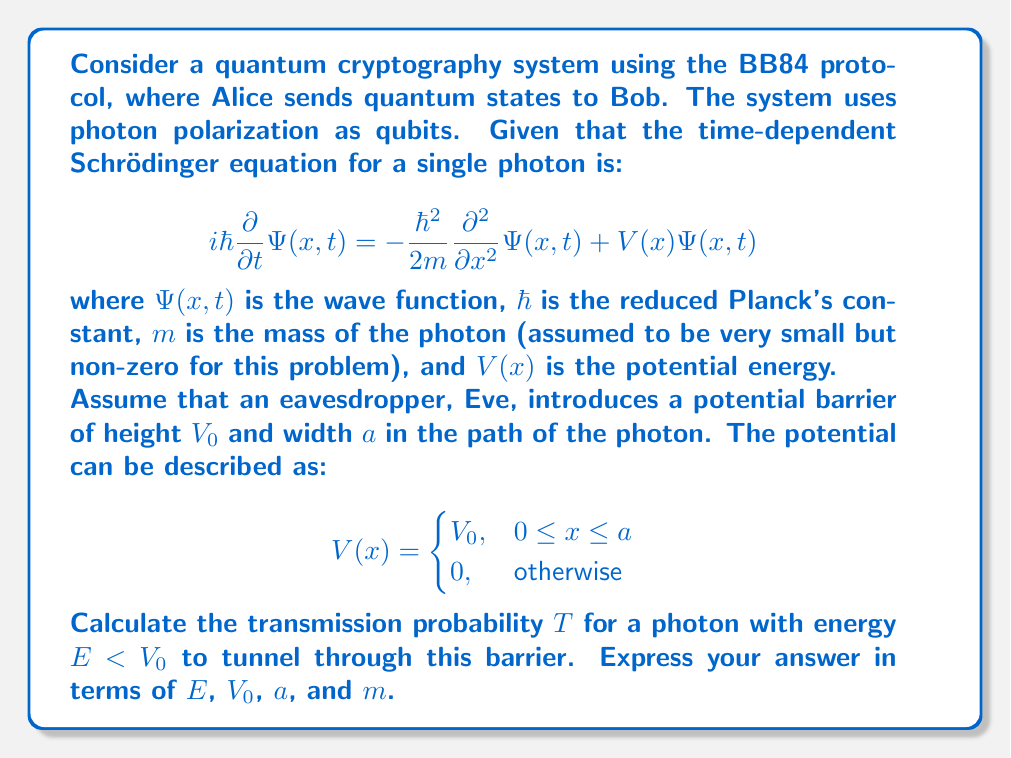What is the answer to this math problem? To solve this problem, we need to follow these steps:

1) First, we recognize that this is a quantum tunneling problem through a rectangular potential barrier.

2) For a time-independent solution, we can separate the wave function into spatial and temporal parts:
   
   $\Psi(x,t) = \psi(x)e^{-iEt/\hbar}$

3) This leads to the time-independent Schrödinger equation:

   $$-\frac{\hbar^2}{2m} \frac{d^2\psi}{dx^2} + V(x)\psi = E\psi$$

4) We need to solve this equation in three regions:
   I: $x < 0$ (before the barrier)
   II: $0 \leq x \leq a$ (inside the barrier)
   III: $x > a$ (after the barrier)

5) The general solutions in each region are:

   I: $\psi_I = Ae^{ikx} + Be^{-ikx}$
   II: $\psi_{II} = Ce^{\kappa x} + De^{-\kappa x}$
   III: $\psi_{III} = Fe^{ikx}$

   Where $k = \sqrt{\frac{2mE}{\hbar^2}}$ and $\kappa = \sqrt{\frac{2m(V_0-E)}{\hbar^2}}$

6) We need to match the wave functions and their derivatives at the boundaries $x=0$ and $x=a$.

7) After applying these boundary conditions and solving the resulting system of equations, we can find the transmission coefficient $T$, which is the ratio of the transmitted intensity to the incident intensity:

   $$T = \left[1 + \frac{V_0^2}{4E(V_0-E)} \sinh^2(\kappa a)\right]^{-1}$$

8) For thin barriers or low energies, we can approximate this as:

   $$T \approx 16\frac{E}{V_0}\left(1-\frac{E}{V_0}\right)e^{-2\kappa a}$$

   Where $\kappa = \sqrt{\frac{2m(V_0-E)}{\hbar^2}}$ as before.

This transmission probability represents the chance that Eve's intervention will allow the photon to pass through, potentially without being detected.
Answer: The transmission probability for a photon with energy $E < V_0$ to tunnel through the potential barrier is approximately:

$$T \approx 16\frac{E}{V_0}\left(1-\frac{E}{V_0}\right)e^{-2a\sqrt{\frac{2m(V_0-E)}{\hbar^2}}}$$

Where $E$ is the photon's energy, $V_0$ is the barrier height, $a$ is the barrier width, $m$ is the photon's effective mass, and $\hbar$ is the reduced Planck's constant. 